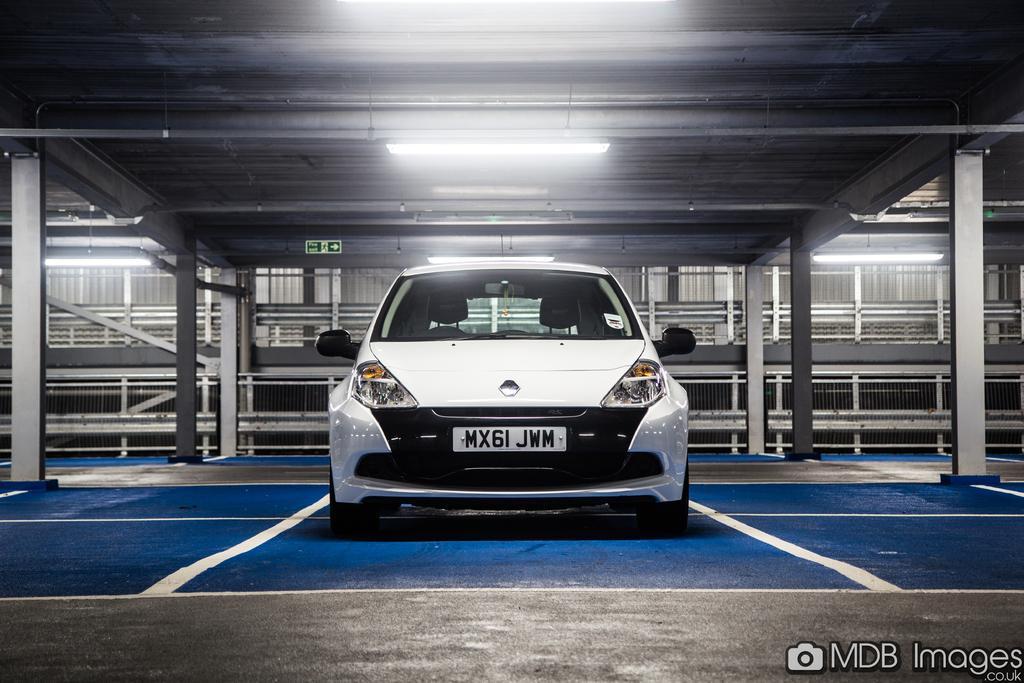Could you give a brief overview of what you see in this image? In the picture we can see a car parked on the blue surface in the parking area and the car is white in color and in the background, we can see some pillars and to the ceiling we can see a light board and exit. 